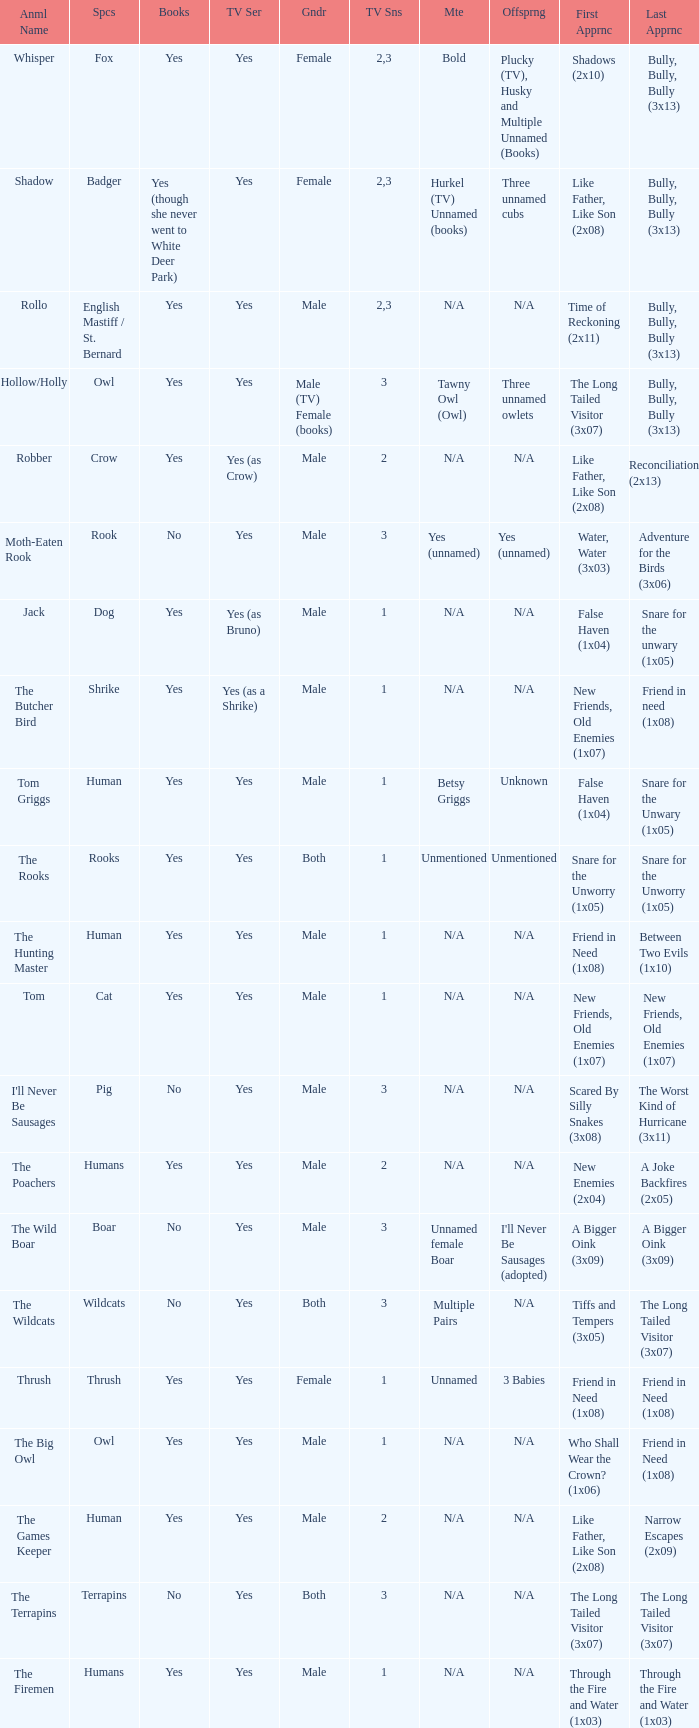What is the smallest season for a tv series with a yes and human was the species? 1.0. 